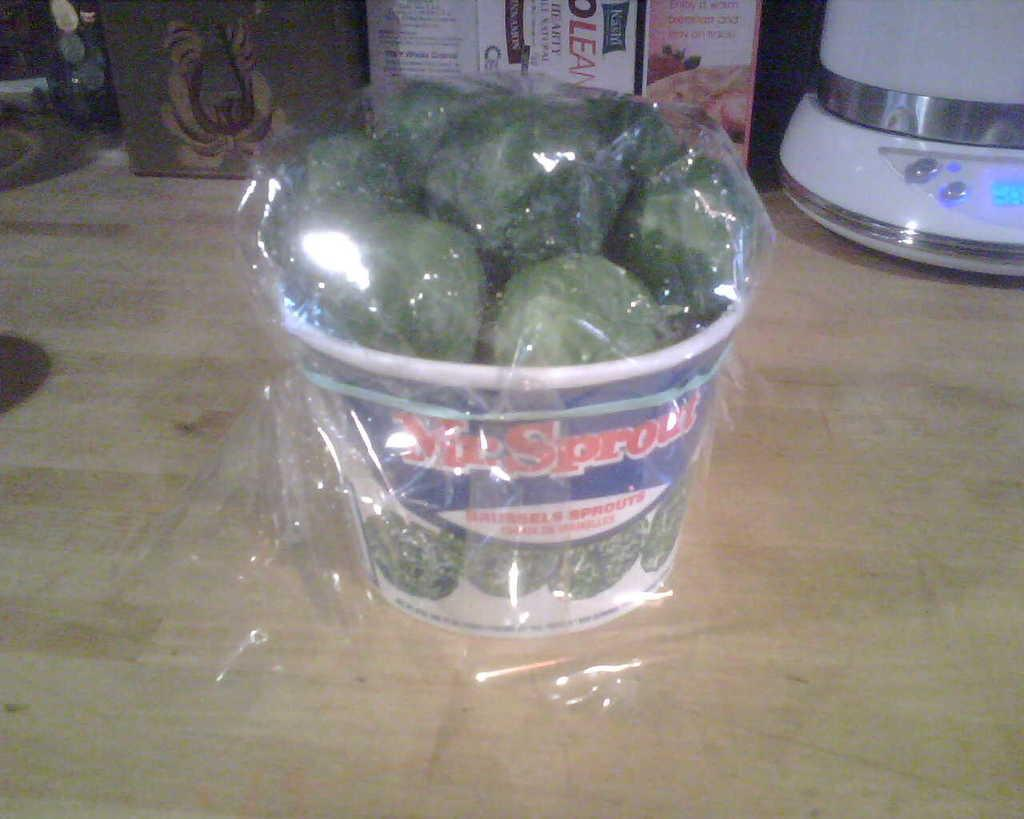<image>
Write a terse but informative summary of the picture. a bucket of broccoli that says sprout on it 